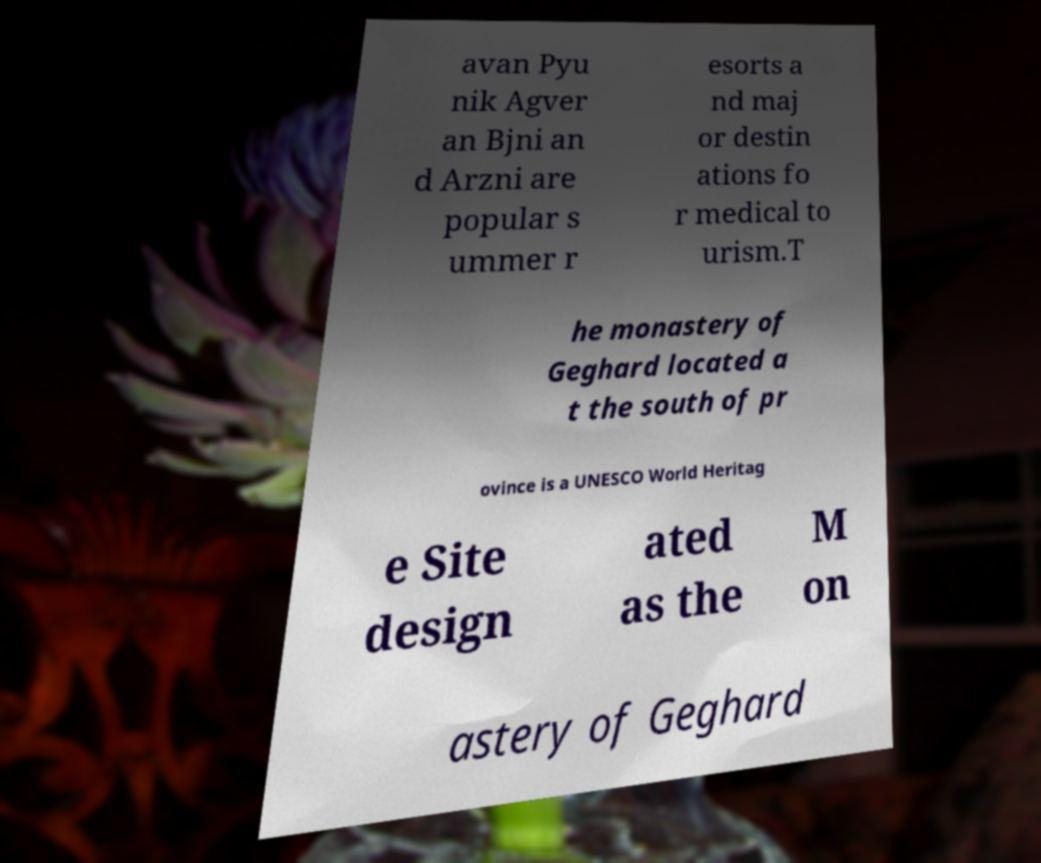Could you extract and type out the text from this image? avan Pyu nik Agver an Bjni an d Arzni are popular s ummer r esorts a nd maj or destin ations fo r medical to urism.T he monastery of Geghard located a t the south of pr ovince is a UNESCO World Heritag e Site design ated as the M on astery of Geghard 